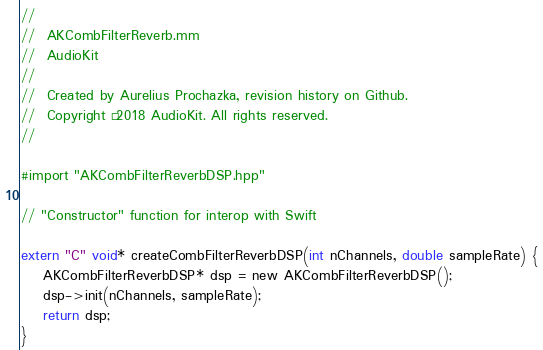<code> <loc_0><loc_0><loc_500><loc_500><_ObjectiveC_>//
//  AKCombFilterReverb.mm
//  AudioKit
//
//  Created by Aurelius Prochazka, revision history on Github.
//  Copyright © 2018 AudioKit. All rights reserved.
//

#import "AKCombFilterReverbDSP.hpp"

// "Constructor" function for interop with Swift

extern "C" void* createCombFilterReverbDSP(int nChannels, double sampleRate) {
    AKCombFilterReverbDSP* dsp = new AKCombFilterReverbDSP();
    dsp->init(nChannels, sampleRate);
    return dsp;
}
</code> 